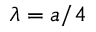<formula> <loc_0><loc_0><loc_500><loc_500>\lambda = a / 4</formula> 